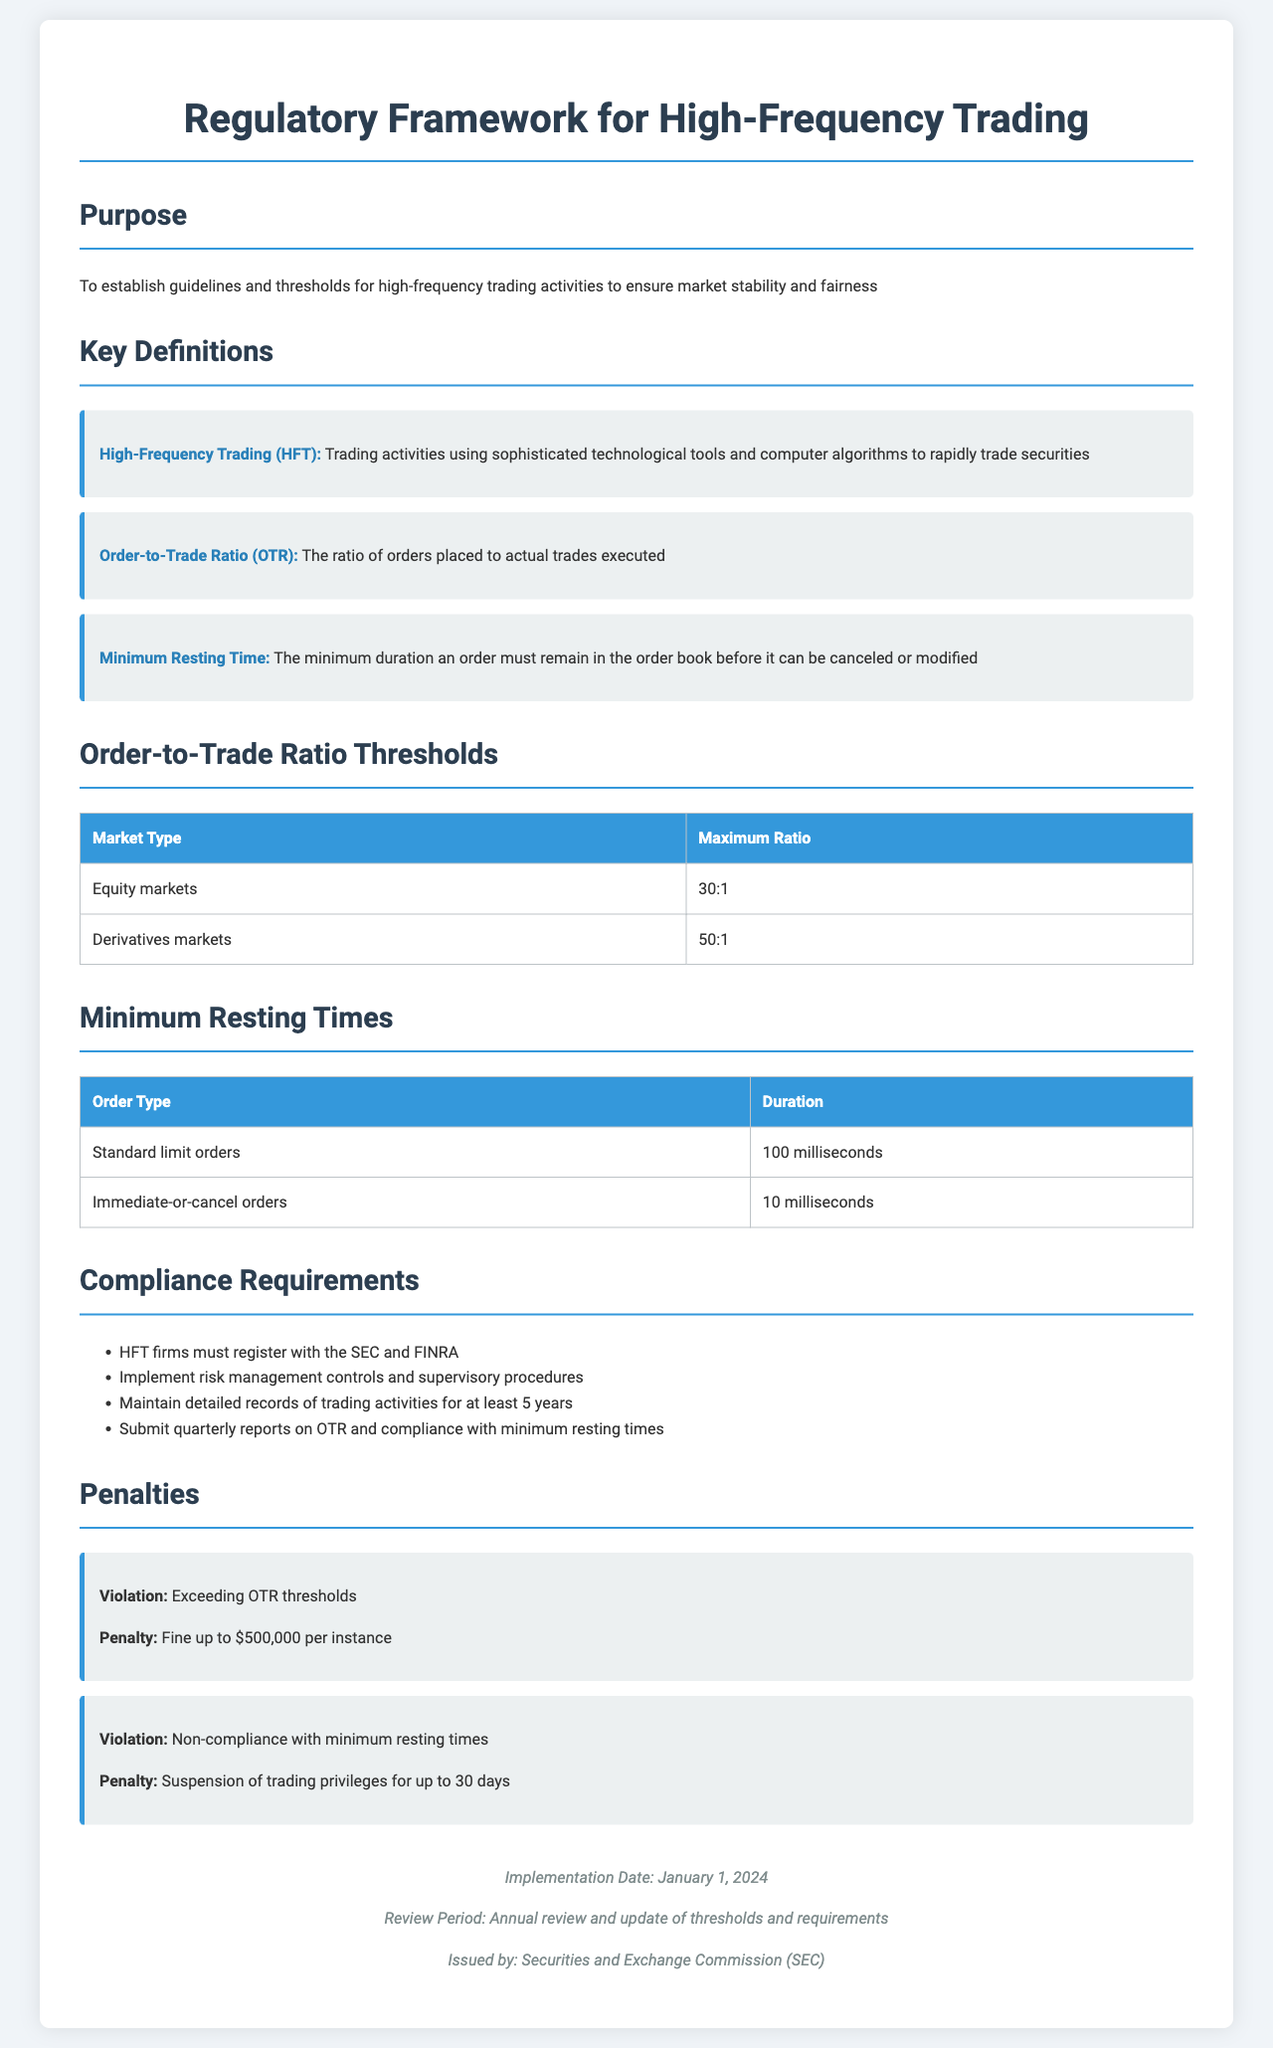What is the maximum Order-to-Trade Ratio for equity markets? The document states the maximum Order-to-Trade Ratio for equity markets as 30:1.
Answer: 30:1 What is the duration for a standard limit order's minimum resting time? According to the document, the minimum resting time for standard limit orders is 100 milliseconds.
Answer: 100 milliseconds What is the penalty for exceeding OTR thresholds? The penalty for exceeding OTR thresholds is a fine up to $500,000 per instance.
Answer: $500,000 Which regulatory bodies must HFT firms register with? The document mentions that HFT firms must register with the SEC and FINRA.
Answer: SEC and FINRA When is the implementation date of this regulatory framework? The document specifies the implementation date as January 1, 2024.
Answer: January 1, 2024 How often should HFT firms submit reports on OTR? The document indicates that HFT firms must submit quarterly reports on OTR.
Answer: Quarterly What is the minimum resting time for immediate-or-cancel orders? The document outlines the minimum resting time for immediate-or-cancel orders as 10 milliseconds.
Answer: 10 milliseconds What is the required record retention period for trading activities? The document states that firms must maintain detailed records of trading activities for at least 5 years.
Answer: 5 years 